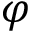<formula> <loc_0><loc_0><loc_500><loc_500>\varphi</formula> 